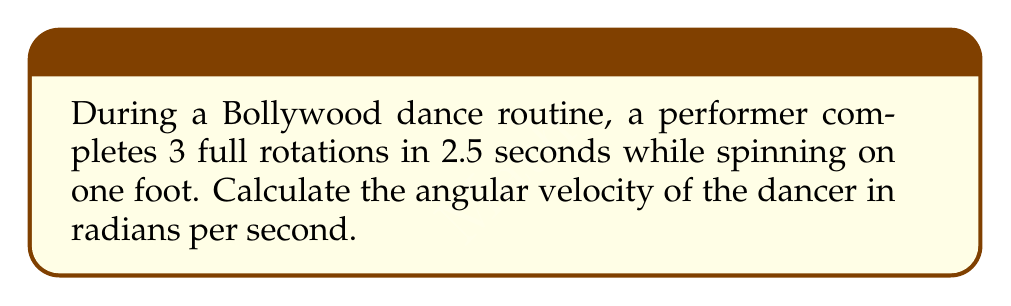Could you help me with this problem? Let's approach this step-by-step:

1) First, we need to understand what angular velocity means. Angular velocity (ω) is the rate of change of angular position with respect to time. It is measured in radians per second (rad/s).

2) We know that one full rotation equals 2π radians. So, 3 full rotations equal:
   $$3 \times 2\pi = 6\pi \text{ radians}$$

3) The time taken for these rotations is 2.5 seconds.

4) The formula for angular velocity is:
   $$\omega = \frac{\Delta \theta}{\Delta t}$$
   Where Δθ is the change in angular position and Δt is the change in time.

5) Substituting our values:
   $$\omega = \frac{6\pi \text{ radians}}{2.5 \text{ seconds}}$$

6) Simplifying:
   $$\omega = \frac{12\pi}{5} \text{ rad/s}$$

7) This can be left as is, or if a decimal approximation is desired:
   $$\omega \approx 7.54 \text{ rad/s}$$
Answer: $\frac{12\pi}{5} \text{ rad/s}$ 